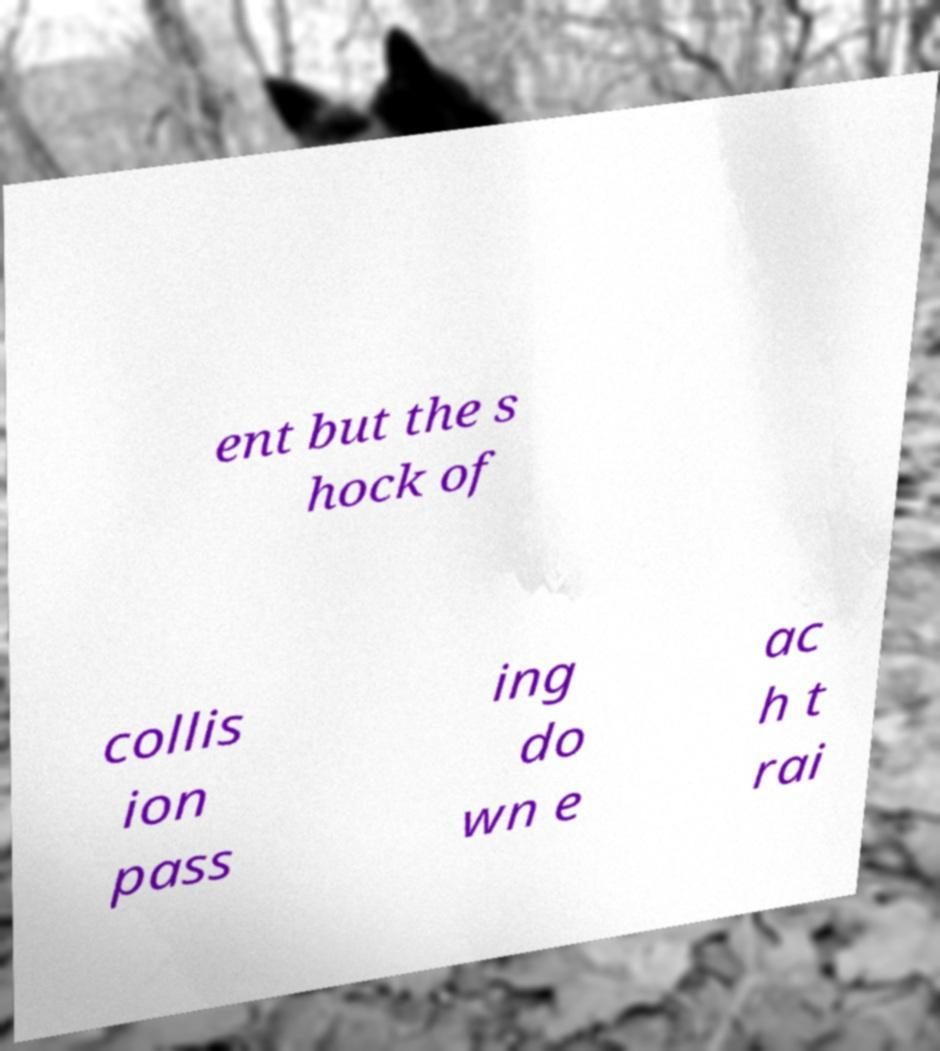For documentation purposes, I need the text within this image transcribed. Could you provide that? ent but the s hock of collis ion pass ing do wn e ac h t rai 